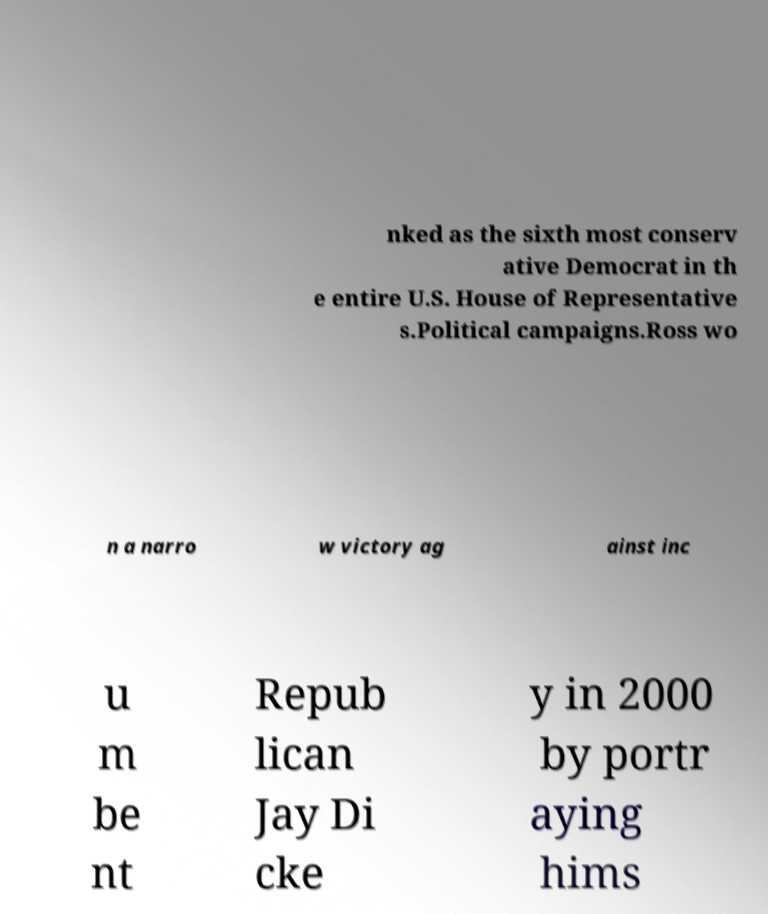Could you extract and type out the text from this image? nked as the sixth most conserv ative Democrat in th e entire U.S. House of Representative s.Political campaigns.Ross wo n a narro w victory ag ainst inc u m be nt Repub lican Jay Di cke y in 2000 by portr aying hims 